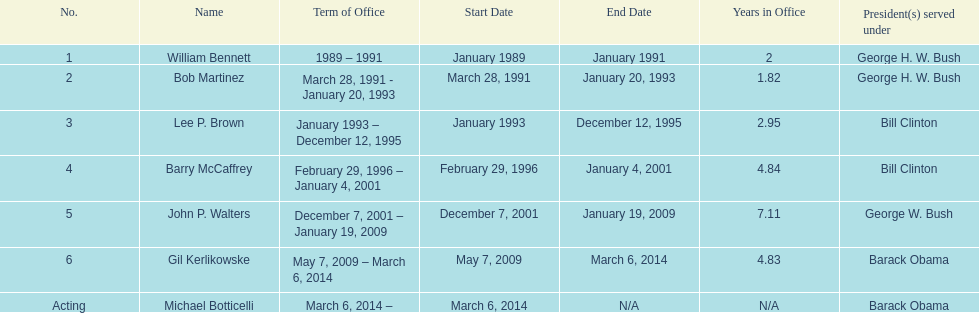How long did bob martinez serve as director? 2 years. 